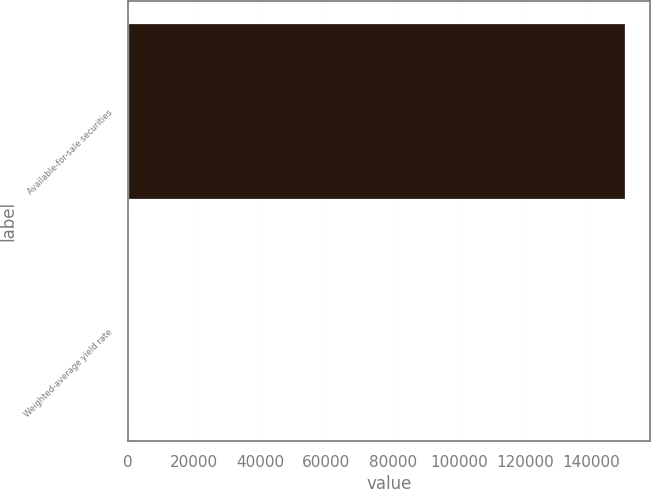<chart> <loc_0><loc_0><loc_500><loc_500><bar_chart><fcel>Available-for-sale securities<fcel>Weighted-average yield rate<nl><fcel>150227<fcel>1.22<nl></chart> 